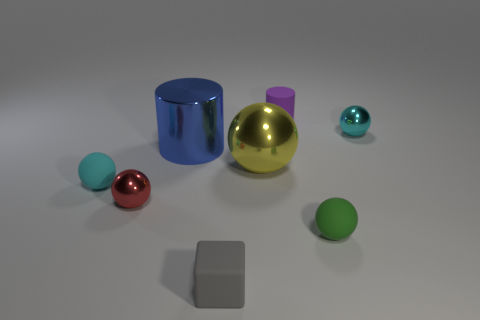Subtract all red balls. How many balls are left? 4 Subtract all big yellow spheres. How many spheres are left? 4 Subtract all gray spheres. Subtract all cyan blocks. How many spheres are left? 5 Add 1 cyan metal cylinders. How many objects exist? 9 Subtract all cylinders. How many objects are left? 6 Add 3 blue metal objects. How many blue metal objects are left? 4 Add 8 purple things. How many purple things exist? 9 Subtract 0 purple cubes. How many objects are left? 8 Subtract all green objects. Subtract all purple rubber cylinders. How many objects are left? 6 